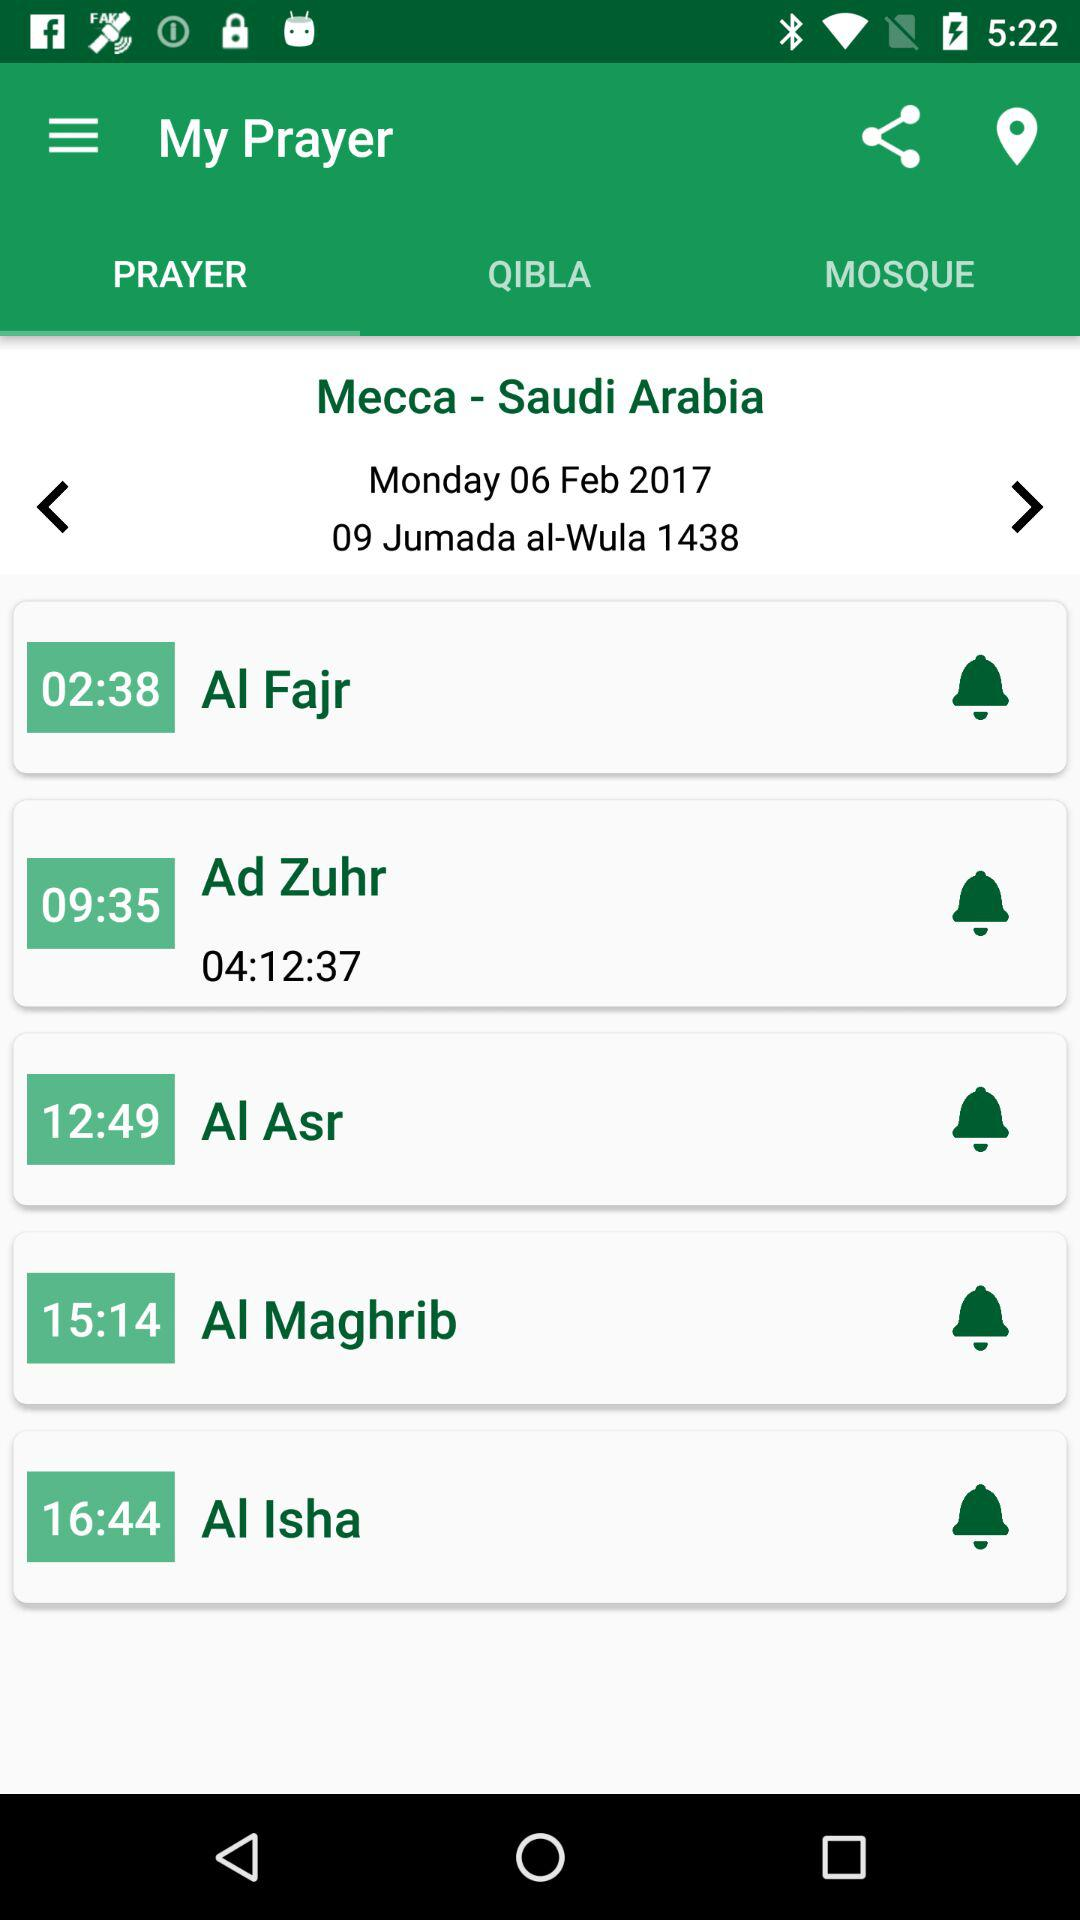What date has been selected in the calendar for offering prayers in Mecca-Saudi Arabia? The selected date is Monday, February 06, 2017. 